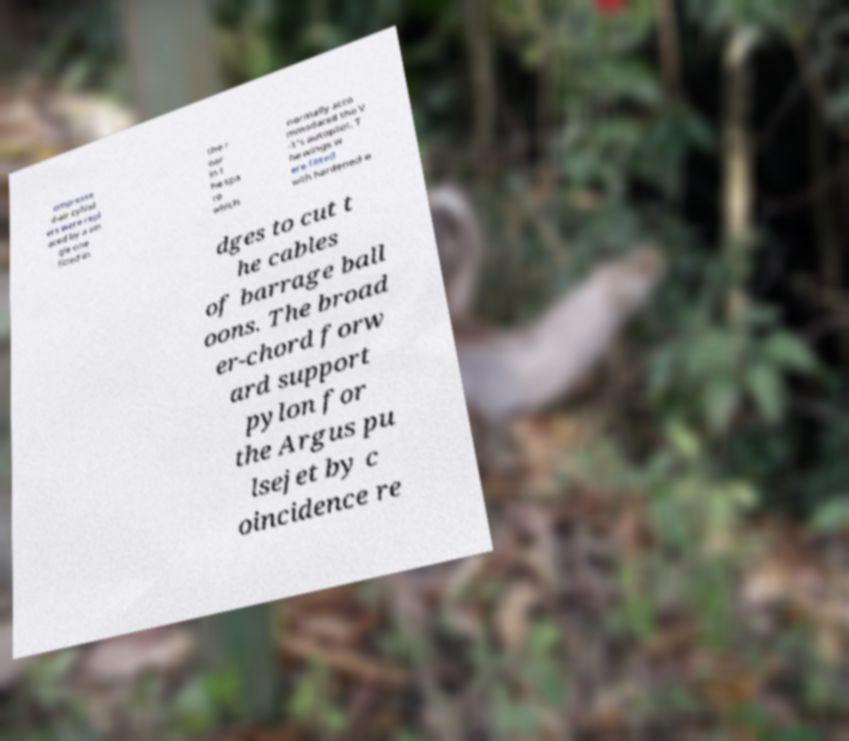Could you extract and type out the text from this image? ompresse d-air cylind ers were repl aced by a sin gle one fitted in the r ear in t he spa ce which normally acco mmodated the V -1's autopilot. T he wings w ere fitted with hardened e dges to cut t he cables of barrage ball oons. The broad er-chord forw ard support pylon for the Argus pu lsejet by c oincidence re 